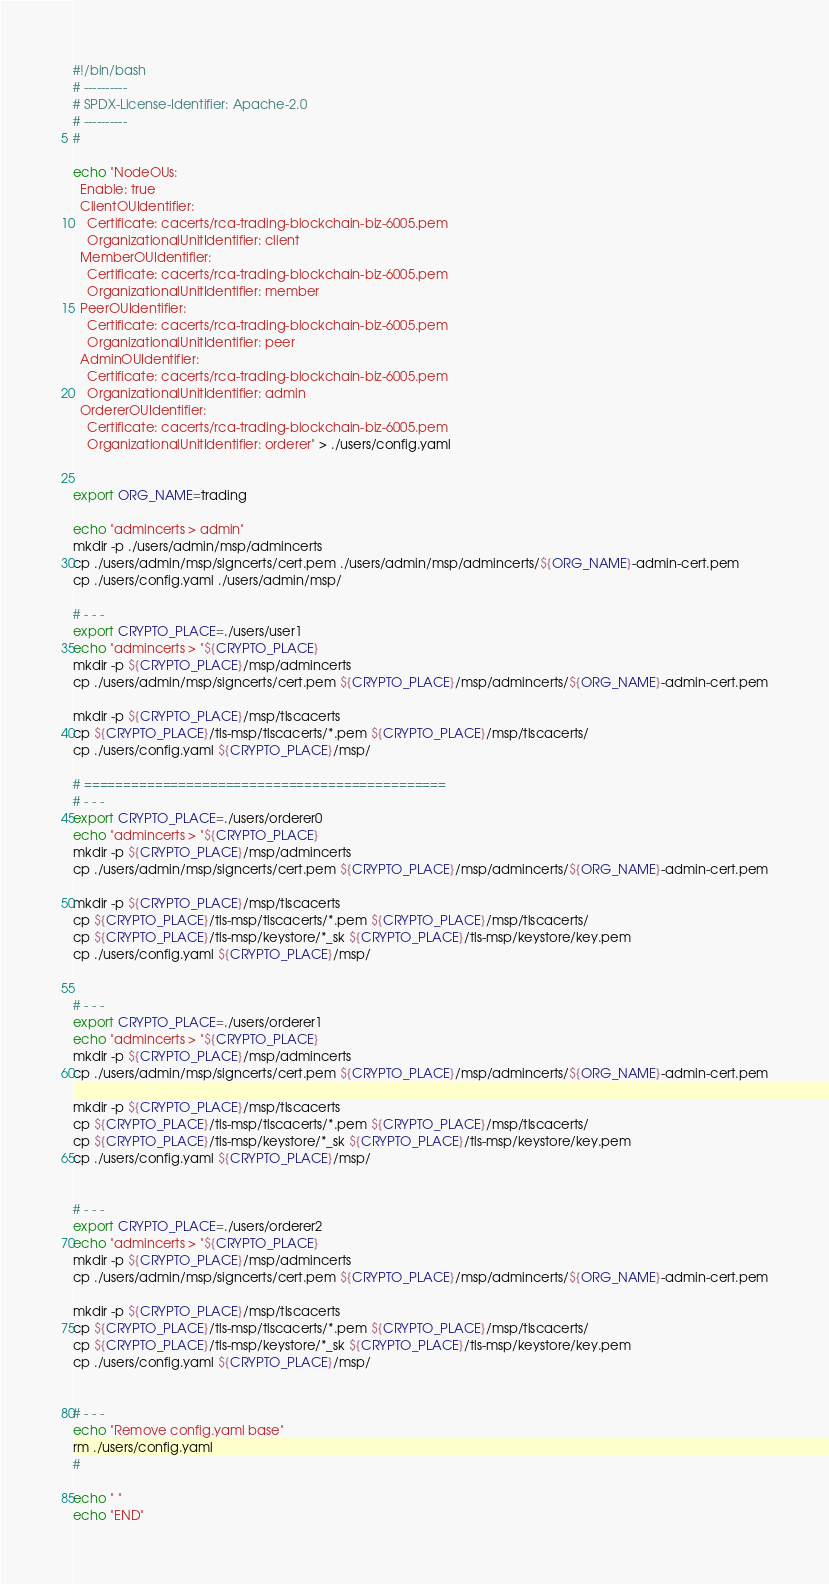Convert code to text. <code><loc_0><loc_0><loc_500><loc_500><_Bash_>#!/bin/bash
# ----------
# SPDX-License-Identifier: Apache-2.0
# ----------
#

echo "NodeOUs:
  Enable: true
  ClientOUIdentifier:
    Certificate: cacerts/rca-trading-blockchain-biz-6005.pem
    OrganizationalUnitIdentifier: client
  MemberOUIdentifier:
    Certificate: cacerts/rca-trading-blockchain-biz-6005.pem
    OrganizationalUnitIdentifier: member
  PeerOUIdentifier:
    Certificate: cacerts/rca-trading-blockchain-biz-6005.pem
    OrganizationalUnitIdentifier: peer
  AdminOUIdentifier:
    Certificate: cacerts/rca-trading-blockchain-biz-6005.pem
    OrganizationalUnitIdentifier: admin
  OrdererOUIdentifier:
    Certificate: cacerts/rca-trading-blockchain-biz-6005.pem
    OrganizationalUnitIdentifier: orderer" > ./users/config.yaml


export ORG_NAME=trading

echo "admincerts > admin"
mkdir -p ./users/admin/msp/admincerts
cp ./users/admin/msp/signcerts/cert.pem ./users/admin/msp/admincerts/${ORG_NAME}-admin-cert.pem
cp ./users/config.yaml ./users/admin/msp/

# - - - 
export CRYPTO_PLACE=./users/user1
echo "admincerts > "${CRYPTO_PLACE}
mkdir -p ${CRYPTO_PLACE}/msp/admincerts
cp ./users/admin/msp/signcerts/cert.pem ${CRYPTO_PLACE}/msp/admincerts/${ORG_NAME}-admin-cert.pem

mkdir -p ${CRYPTO_PLACE}/msp/tlscacerts
cp ${CRYPTO_PLACE}/tls-msp/tlscacerts/*.pem ${CRYPTO_PLACE}/msp/tlscacerts/
cp ./users/config.yaml ${CRYPTO_PLACE}/msp/

# ==============================================
# - - - 
export CRYPTO_PLACE=./users/orderer0
echo "admincerts > "${CRYPTO_PLACE}
mkdir -p ${CRYPTO_PLACE}/msp/admincerts
cp ./users/admin/msp/signcerts/cert.pem ${CRYPTO_PLACE}/msp/admincerts/${ORG_NAME}-admin-cert.pem

mkdir -p ${CRYPTO_PLACE}/msp/tlscacerts
cp ${CRYPTO_PLACE}/tls-msp/tlscacerts/*.pem ${CRYPTO_PLACE}/msp/tlscacerts/
cp ${CRYPTO_PLACE}/tls-msp/keystore/*_sk ${CRYPTO_PLACE}/tls-msp/keystore/key.pem
cp ./users/config.yaml ${CRYPTO_PLACE}/msp/


# - - - 
export CRYPTO_PLACE=./users/orderer1
echo "admincerts > "${CRYPTO_PLACE}
mkdir -p ${CRYPTO_PLACE}/msp/admincerts
cp ./users/admin/msp/signcerts/cert.pem ${CRYPTO_PLACE}/msp/admincerts/${ORG_NAME}-admin-cert.pem

mkdir -p ${CRYPTO_PLACE}/msp/tlscacerts
cp ${CRYPTO_PLACE}/tls-msp/tlscacerts/*.pem ${CRYPTO_PLACE}/msp/tlscacerts/
cp ${CRYPTO_PLACE}/tls-msp/keystore/*_sk ${CRYPTO_PLACE}/tls-msp/keystore/key.pem
cp ./users/config.yaml ${CRYPTO_PLACE}/msp/


# - - - 
export CRYPTO_PLACE=./users/orderer2
echo "admincerts > "${CRYPTO_PLACE}
mkdir -p ${CRYPTO_PLACE}/msp/admincerts
cp ./users/admin/msp/signcerts/cert.pem ${CRYPTO_PLACE}/msp/admincerts/${ORG_NAME}-admin-cert.pem

mkdir -p ${CRYPTO_PLACE}/msp/tlscacerts
cp ${CRYPTO_PLACE}/tls-msp/tlscacerts/*.pem ${CRYPTO_PLACE}/msp/tlscacerts/
cp ${CRYPTO_PLACE}/tls-msp/keystore/*_sk ${CRYPTO_PLACE}/tls-msp/keystore/key.pem
cp ./users/config.yaml ${CRYPTO_PLACE}/msp/


# - - - 
echo "Remove config.yaml base"
rm ./users/config.yaml
#

echo " "
echo "END"
</code> 